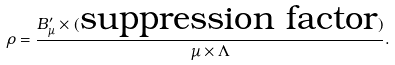Convert formula to latex. <formula><loc_0><loc_0><loc_500><loc_500>\rho = \frac { B _ { \mu } ^ { \prime } \times ( \text {suppression factor} ) } { \mu \times \Lambda } .</formula> 